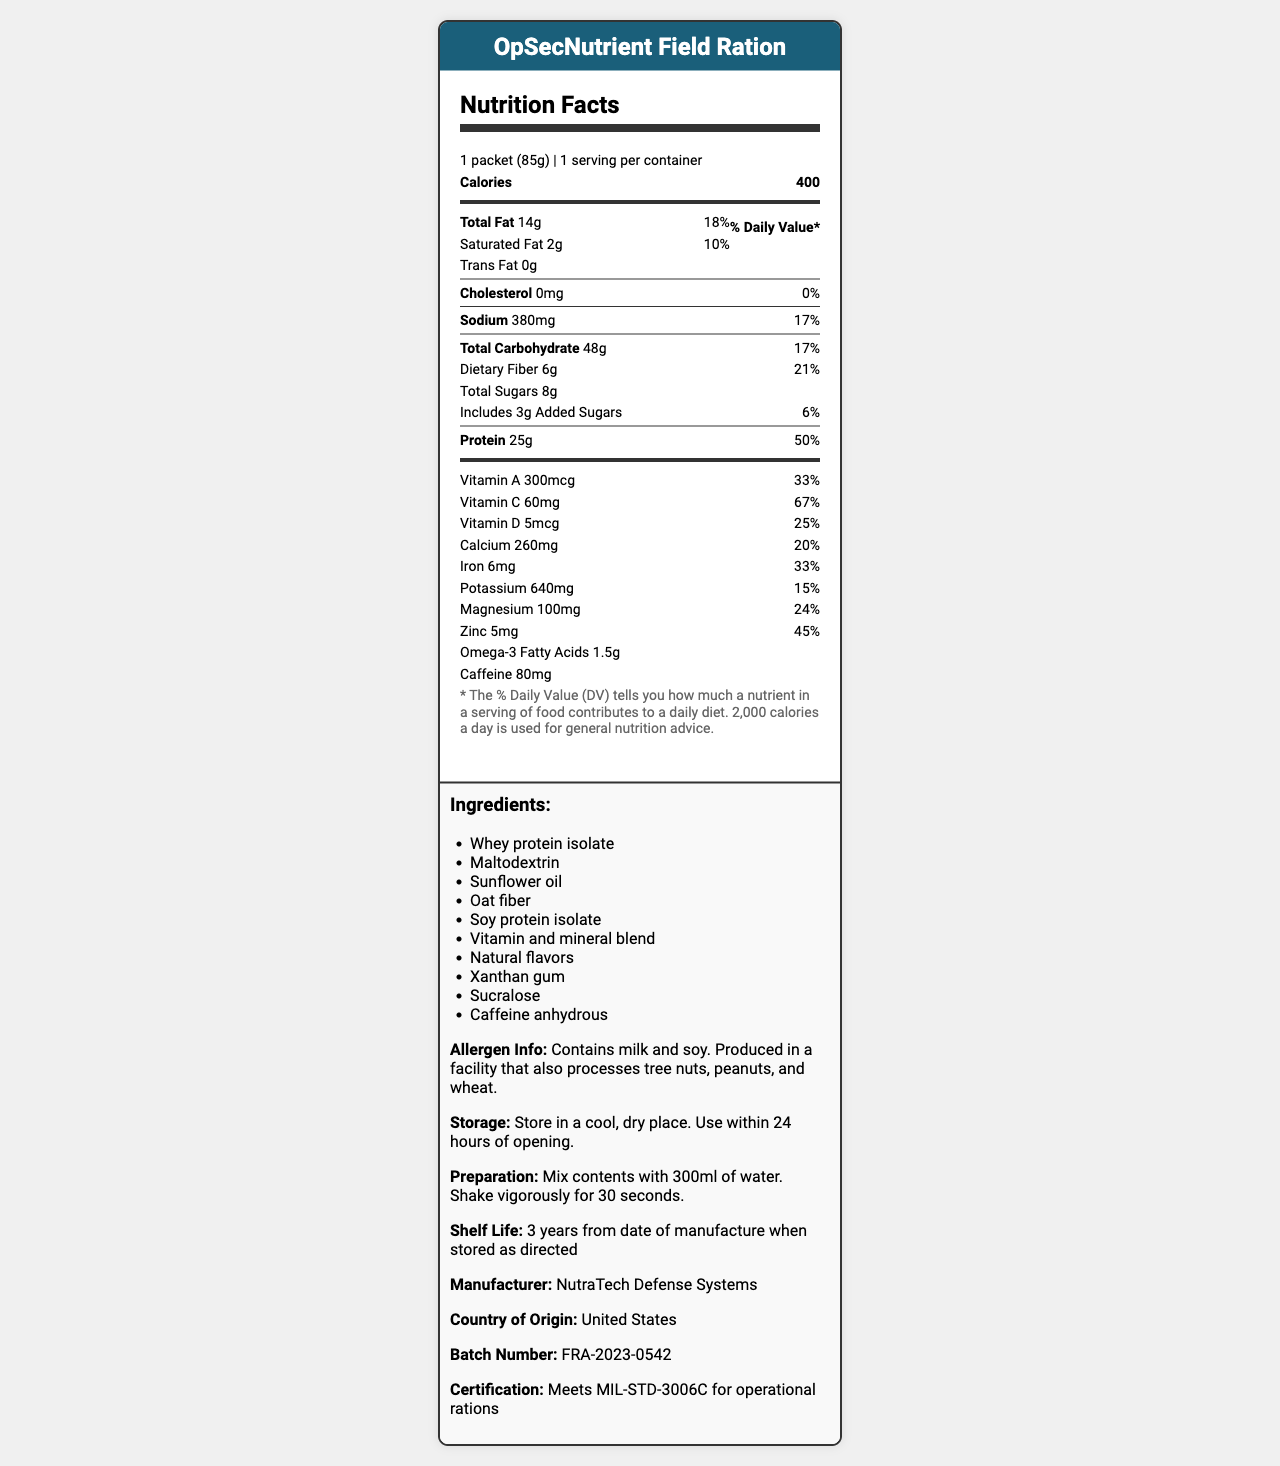what is the serving size for the product? The serving size is explicitly mentioned in the document as "1 packet (85g)".
Answer: 1 packet (85g) how many servings are there per container? The document states that there is 1 serving per container.
Answer: 1 how many calories are in one serving of this product? The number of calories is listed as 400 in the nutrition facts section.
Answer: 400 what is the total amount of fat in the product, and what percentage of daily value does it represent? The document states that the total fat is 14g which is 18% of the daily value.
Answer: 14g, 18% what are the instructions for preparing the product? The preparation instructions are listed as "Mix contents with 300ml of water. Shake vigorously for 30 seconds."
Answer: Mix contents with 300ml of water. Shake vigorously for 30 seconds. which of the following facts about the product is true?
A. It contains tree nuts.
B. It has 60mg of vitamin C.
C. The shelf life is 2 years. The document mentions that the product has 60mg of vitamin C. The allergen info states it is produced in a facility that processes tree nuts but does not necessarily contain them. The shelf life is listed as 3 years from the date of manufacture.
Answer: B what is the daily value percentage for vitamin D in this product? A. 33% B. 20% C. 25% D. 67% The document lists the daily value percentage for vitamin D as 25%.
Answer: C does the product contain any trans fat? The document shows that the amount of trans fat in the product is 0g.
Answer: No summarize the key information in this document. This summary captures all the significant sections and details presented in the document.
Answer: The document provides detailed nutrition facts for the "OpSecNutrient Field Ration". It includes serving size, servings per container, calories, and a breakdown of various nutrients along with their amounts and daily value percentages. The document also lists the ingredients, allergen information, storage instructions, preparation method, shelf life, manufacturer details, country of origin, batch number, and certification. how much caffeine does each serving of this product contains? The caffeine content per serving is listed as 80mg in the document.
Answer: 80mg what are the two primary protein sources in the ingredients? The ingredients list shows "Whey protein isolate" and "Soy protein isolate" as the primary protein sources.
Answer: Whey protein isolate, Soy protein isolate how much dietary fiber is in the product, and what percentage of daily value does it contribute? The document states the dietary fiber content as 6g which is 21% of the daily value.
Answer: 6g, 21% how should the product be stored after opening? The storage instructions specify that after opening, the product should be stored in a cool, dry place and used within 24 hours.
Answer: Store in a cool, dry place. Use within 24 hours of opening. how much omega-3 fatty acids does one serving of this product provide? The omega-3 fatty acids content is listed as 1.5g in the document.
Answer: 1.5g who is the manufacturer of the product? The manufacturer is mentioned as NutraTech Defense Systems in the document.
Answer: NutraTech Defense Systems what is the percentage of daily value for calcium in this product? The document states that the percentage of daily value for calcium is 20%.
Answer: 20% what certification does the product meet? The document states that the product meets the certification MIL-STD-3006C for operational rations.
Answer: Meets MIL-STD-3006C for operational rations how many grams of added sugars are in the product? The added sugars content is listed as 3g in the document.
Answer: 3g what year was the batch FRA-2023-0542 produced? The batch number indicates the production year as 2023.
Answer: 2023 what is the primary use of this product? The intended use of the product as a meal replacement formula for covert field agents can be inferred, but it is not explicitly stated in the document.
Answer: Cannot be determined 